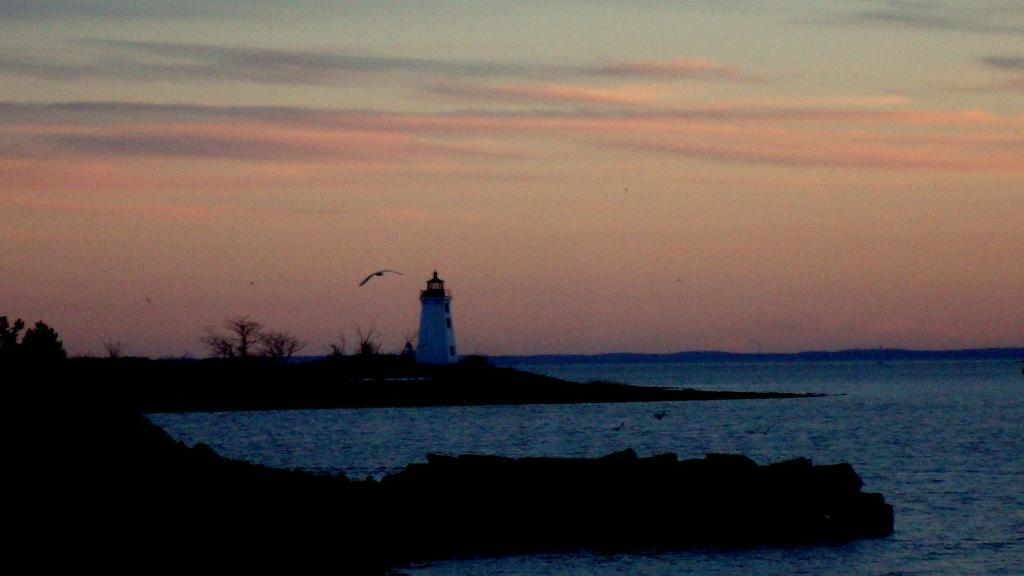What is the primary element in the image? There is water in the image. What structure can be seen near the water? There is a lighthouse in the image. What type of vegetation is present in the image? There are trees in the image. What is the bird in the image doing? A bird is flying in the image. What can be seen in the background of the image? There is a sky with clouds visible in the background of the image. What type of yarn is being used to create the prose in the image? There is no yarn or prose present in the image; it features water, a lighthouse, trees, a bird, and a sky with clouds. 